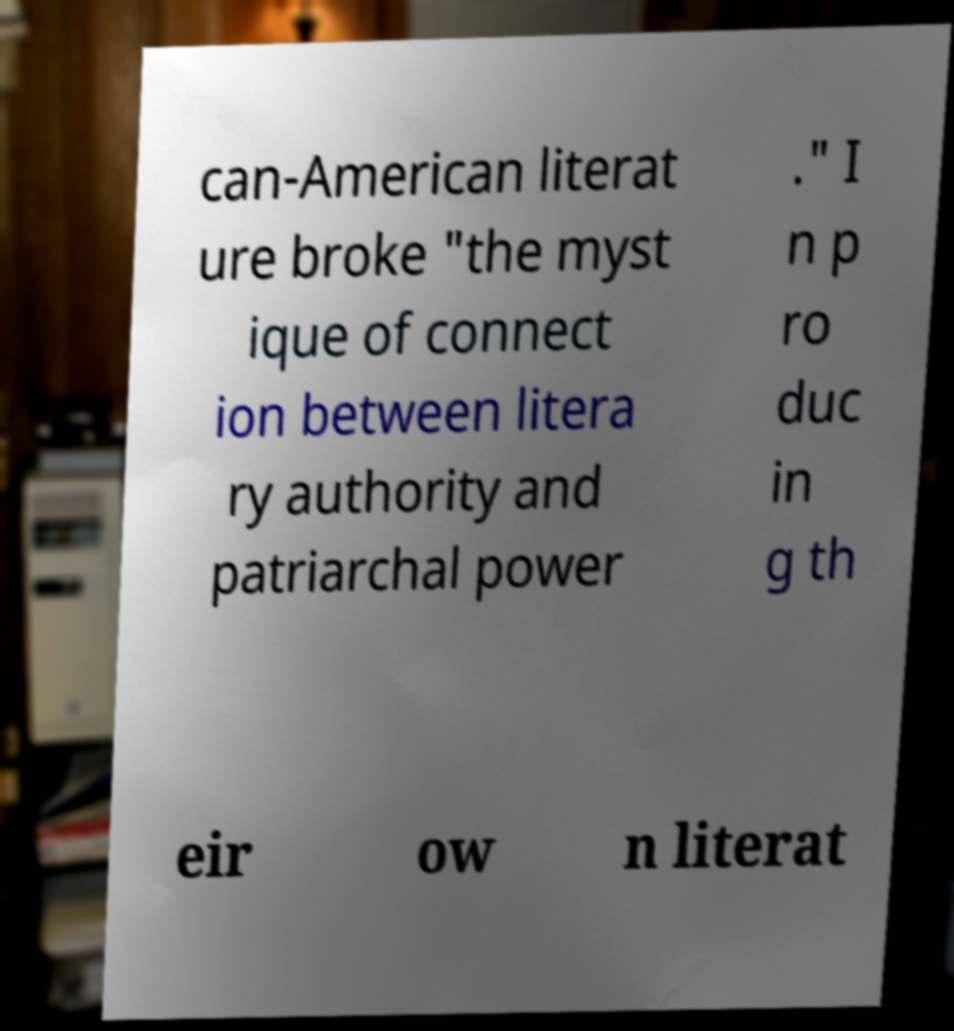Please read and relay the text visible in this image. What does it say? can-American literat ure broke "the myst ique of connect ion between litera ry authority and patriarchal power ." I n p ro duc in g th eir ow n literat 